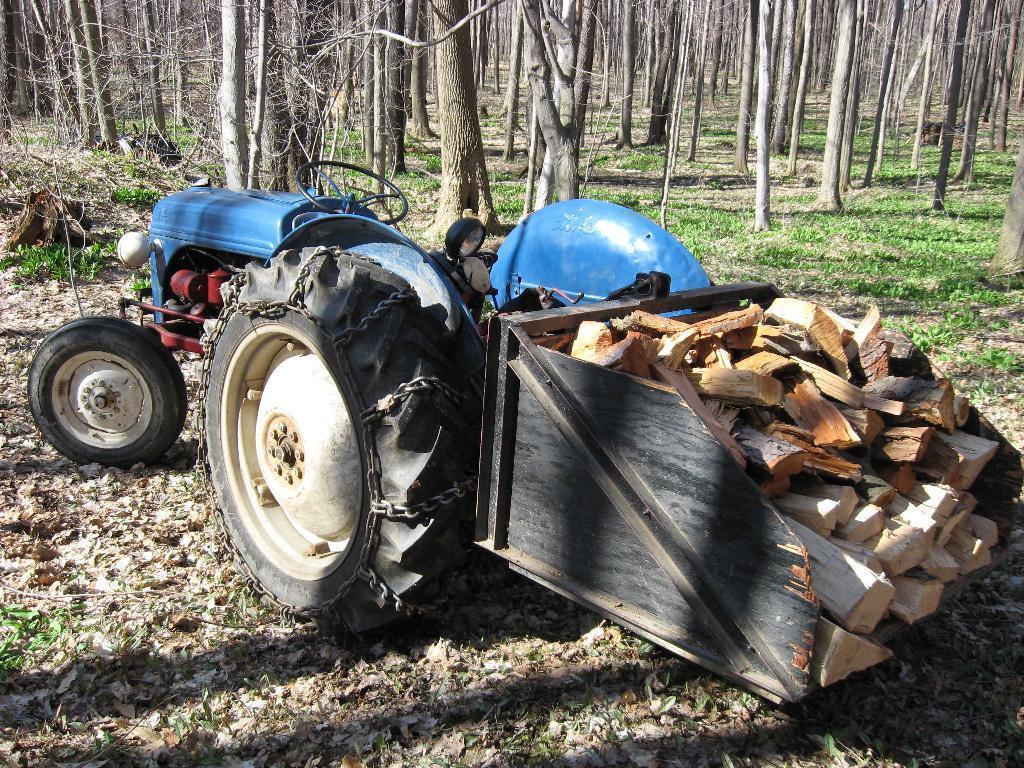Can you describe this image briefly? This picture might be taken from outside of the city and it is very sunny. In this image, in the middle, we can see a tractor, on that tractor there is a wood. In the background, there are some trees, at the bottom there is a grass with some leaves and stones. 